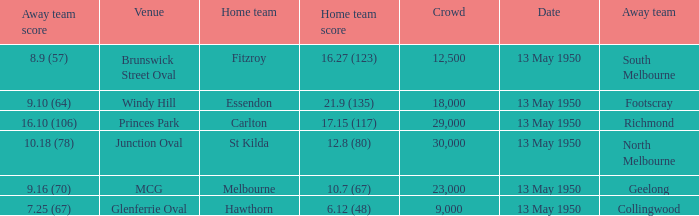What was the lowest crowd size at the Windy Hill venue? 18000.0. 